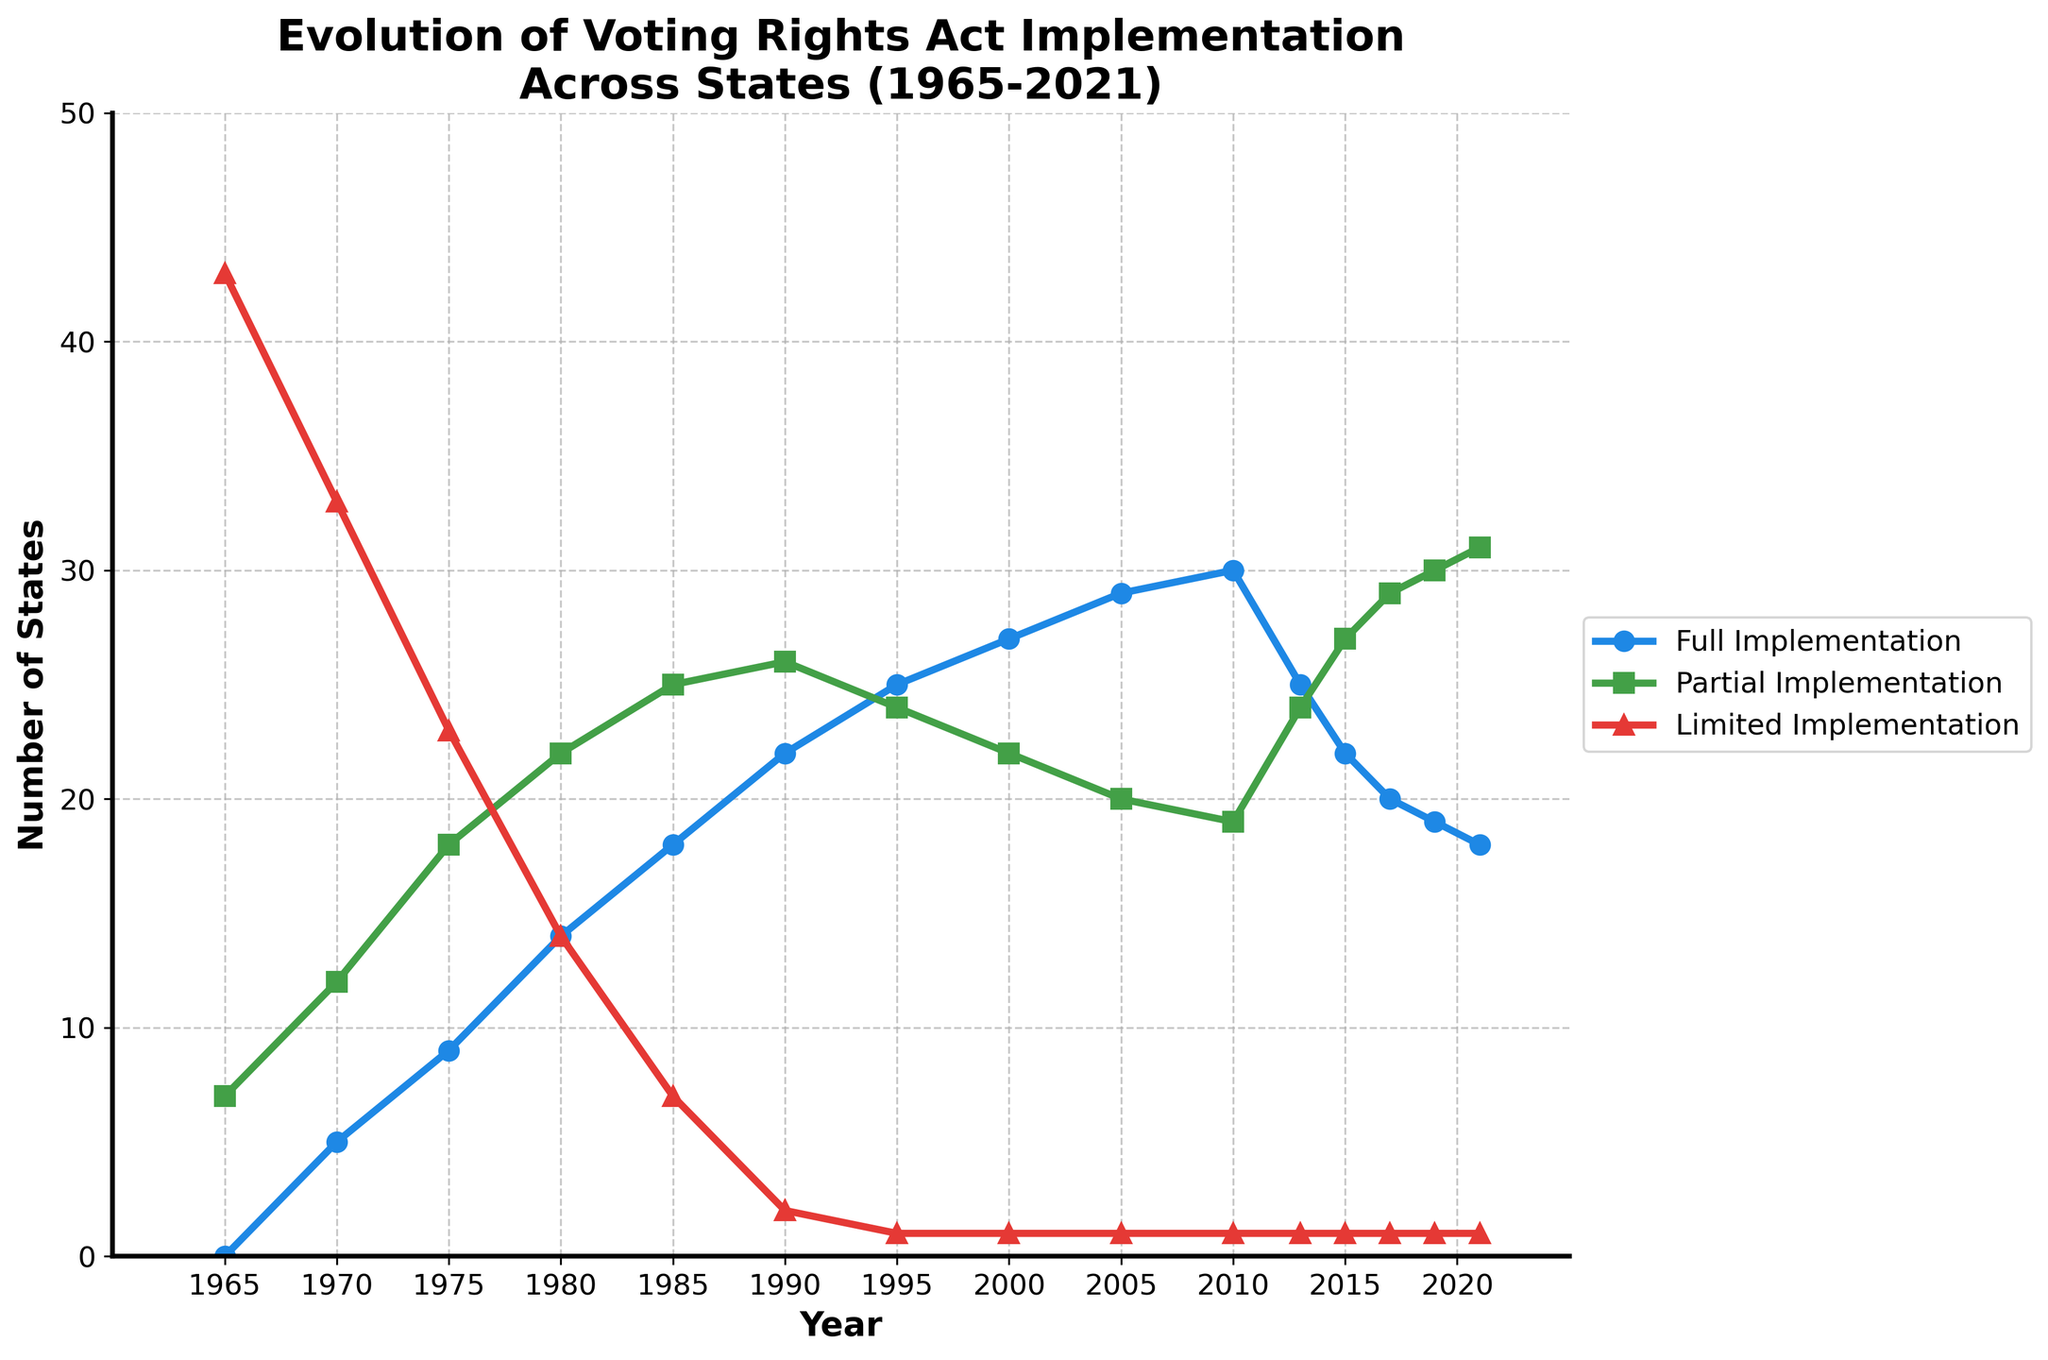What year saw the highest number of states with full VRA implementation? Look at the blue line representing states with full VRA implementation and find the peak point. The highest number of states is 30, occurring in 2010.
Answer: 2010 Which implementation category (Full, Partial, or Limited) experienced the most considerable increase in the number of states from 1965 to 1980? Calculate the increase for each category by subtracting their 1965 values from their 1980 values. For Full: 14-0=14, for Partial: 22-7=15, and for Limited: 14-43=-29. The largest increase is in the Partial category.
Answer: Partial In which years did the number of states with partial VRA implementation exactly equal the number of states with full VRA implementation? Scan the green and blue lines to find the points where their values match. This occurs in 1985 when both have 18 states.
Answer: 1985 How many states transitioned from having limited VRA implementation to partial implementation between 1965 and 1970? Find the difference in the states with limited implementation from 1965 to 1970 and add this to the increase in states with partial implementation. From Limited: 43-33=10, Partial increase by: 12-7=5. So, 10 states moved out of limited, of which 5 went to partial.
Answer: 5 What is the general trend in the number of states with full VRA implementation from 2010 to 2021? Look at the blue line from 2010 to 2021. It initially decreases from 30 in 2010 to 18 in 2021, indicating a downward trend.
Answer: Downward Comparing the years 1990, 2000, and 2010, which year had the highest number of states with limited VRA implementation? Check the red line at these points. In 1990, there are 2 states; in 2000 and 2010, each has 1 state with limited implementation.
Answer: 1990 What is the difference in the number of states with full VRA implementation between 2000 and 2021? Subtract the value for 2021 from that of 2000. In 2000, there are 27 states; in 2021, there are 18 states. The difference is 27 - 18 = 9.
Answer: 9 How many years did it take for the number of states with full VRA implementation to increase from 9 to 30? First note the years when these numbers occur. 9 states in 1975 and 30 states in 2010. Calculate the difference between the years: 2010 - 1975 = 35 years.
Answer: 35 In which year did states with partial VRA implementation outnumber states with limited implementation for the first time? Inspect the green and red lines to see when the green line first crosses above the red line. In 1970, partial implementation (12 states) exceeds limited implementation (33 states).
Answer: 1970 How many states in total had full or partial VRA implementation in 1995? Add the number of states with full and partial implementation for the year 1995. That is: 25 (full) + 24 (partial) = 49 states.
Answer: 49 